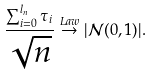<formula> <loc_0><loc_0><loc_500><loc_500>\frac { \sum _ { i = 0 } ^ { l _ { n } } \tau _ { i } } { \sqrt { n } } \stackrel { L a w } { \to } | \mathcal { N } ( 0 , 1 ) | .</formula> 